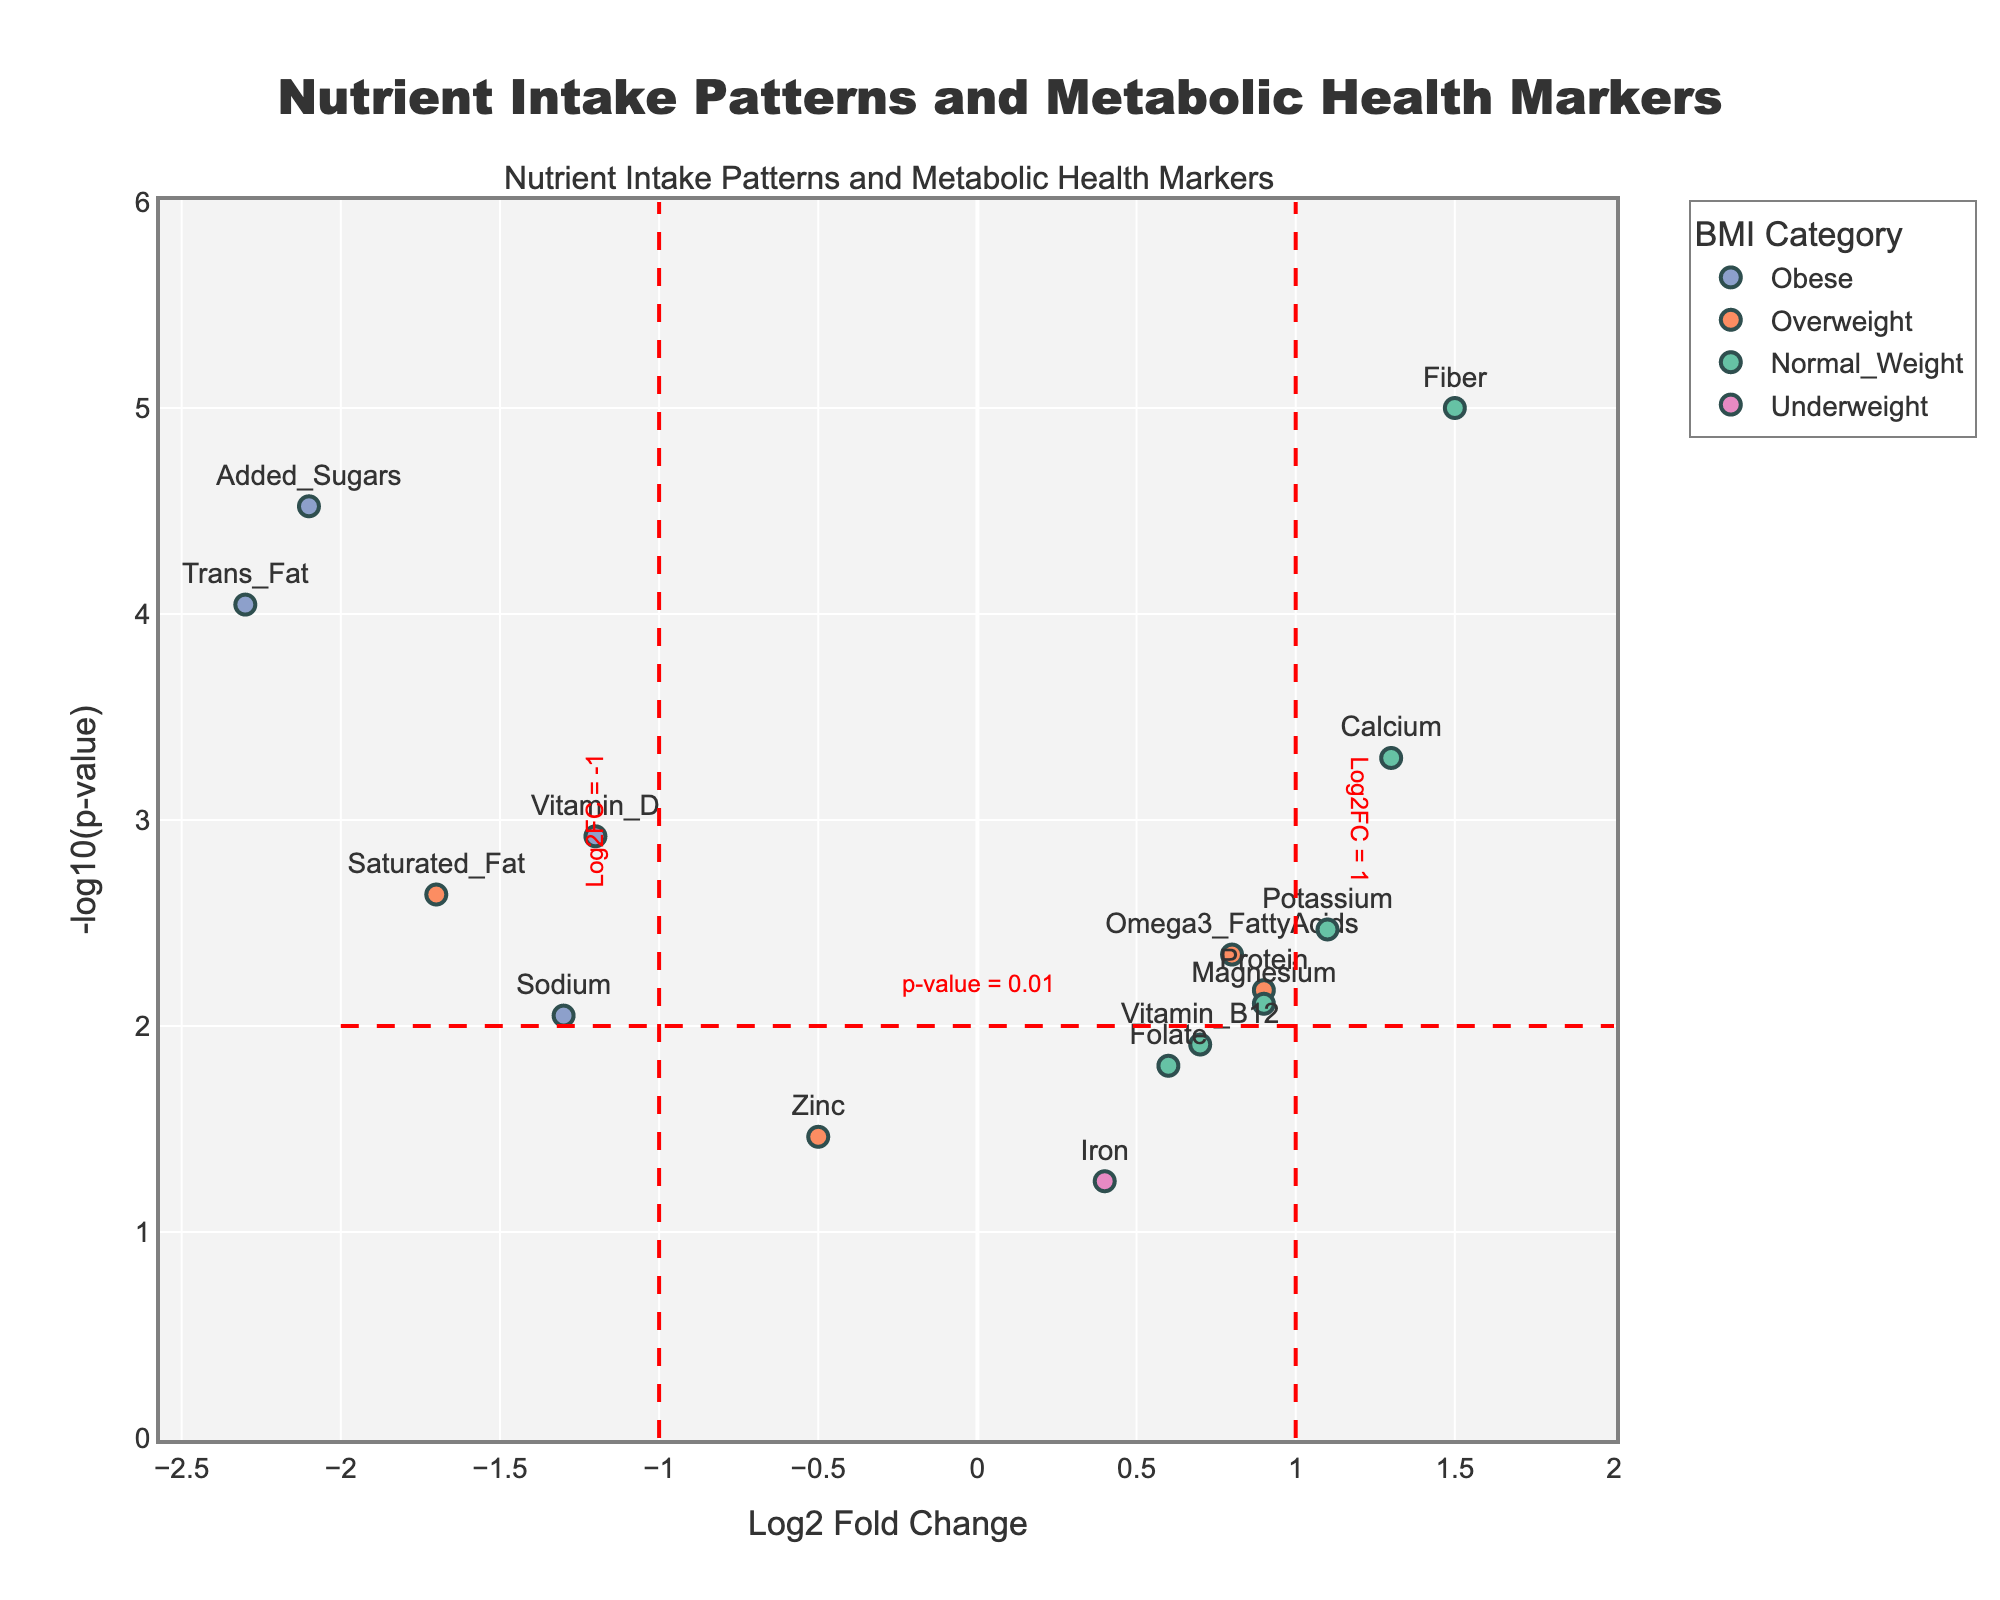What's the title of the plot? The title is displayed at the top of the plot, which typically indicates the main focus or subject being analyzed.
Answer: Nutrient Intake Patterns and Metabolic Health Markers What are the axes' titles and what do they represent? The plot's x-axis is labeled "Log2 Fold Change," representing the log2 transformed fold changes of nutrient intake. The y-axis is labeled "-log10(p-value)," representing the -log10 transformed p-values for the associations.
Answer: Log2 Fold Change and -log10(p-value) Which BMI category has the most data points on the plot? By visually counting the markers grouped by color, we can see which color appears most frequently to determine the BMI category with the most data points.
Answer: Normal_Weight What is the nutrient with the highest statistical significance and its BMI category? Statistical significance is indicated by the highest -log10(p-value). The highest point on the y-axis corresponds to Fiber in the Normal_Weight category.
Answer: Fiber, Normal_Weight How many nutrients have a log2 fold change less than -1? Nutrients with a log2 fold change less than -1 appear to the left of the vertical threshold line at -1. Count these markers.
Answer: 3 Which BMI category shows the most substantial negative association with any nutrient, and what is the nutrient? Substantial negative association is indicated by the lowest log2 fold change. The leftmost point corresponds to Trans_Fat in the Obese category.
Answer: Obese, Trans_Fat Are there any nutrients with both high statistical significance (p-value < 0.01) and positive log2 fold change greater than 1? If so, name them and their corresponding BMI categories. High statistical significance (p-value < 0.01) appears above the horizontal threshold line at -log10(0.01) = 2. Positive log2 fold change greater than 1 appears right of the vertical threshold line at 1. Calcium in the Normal_Weight category meets both conditions.
Answer: Calcium, Normal_Weight What is the log2 fold change and p-value for Vitamin_D and which BMI category does it belong to? The position of Vitamin_D marker gives log2 fold change on the x-axis and -log10(p-value) on the y-axis. Transform -log10(p-value) back to p-value if needed. The nutrient's label and color indicate its BMI category.
Answer: -1.2 log2 fold change, 0.0012 p-value, Obese Which nutrient is closest to the p-value threshold line and what BMI category does it belong to? The nutrient closest to the horizontal threshold line at -log10(0.01) just above or below corresponds to Magnesium in the Normal_Weight category.
Answer: Magnesium, Normal_Weight 